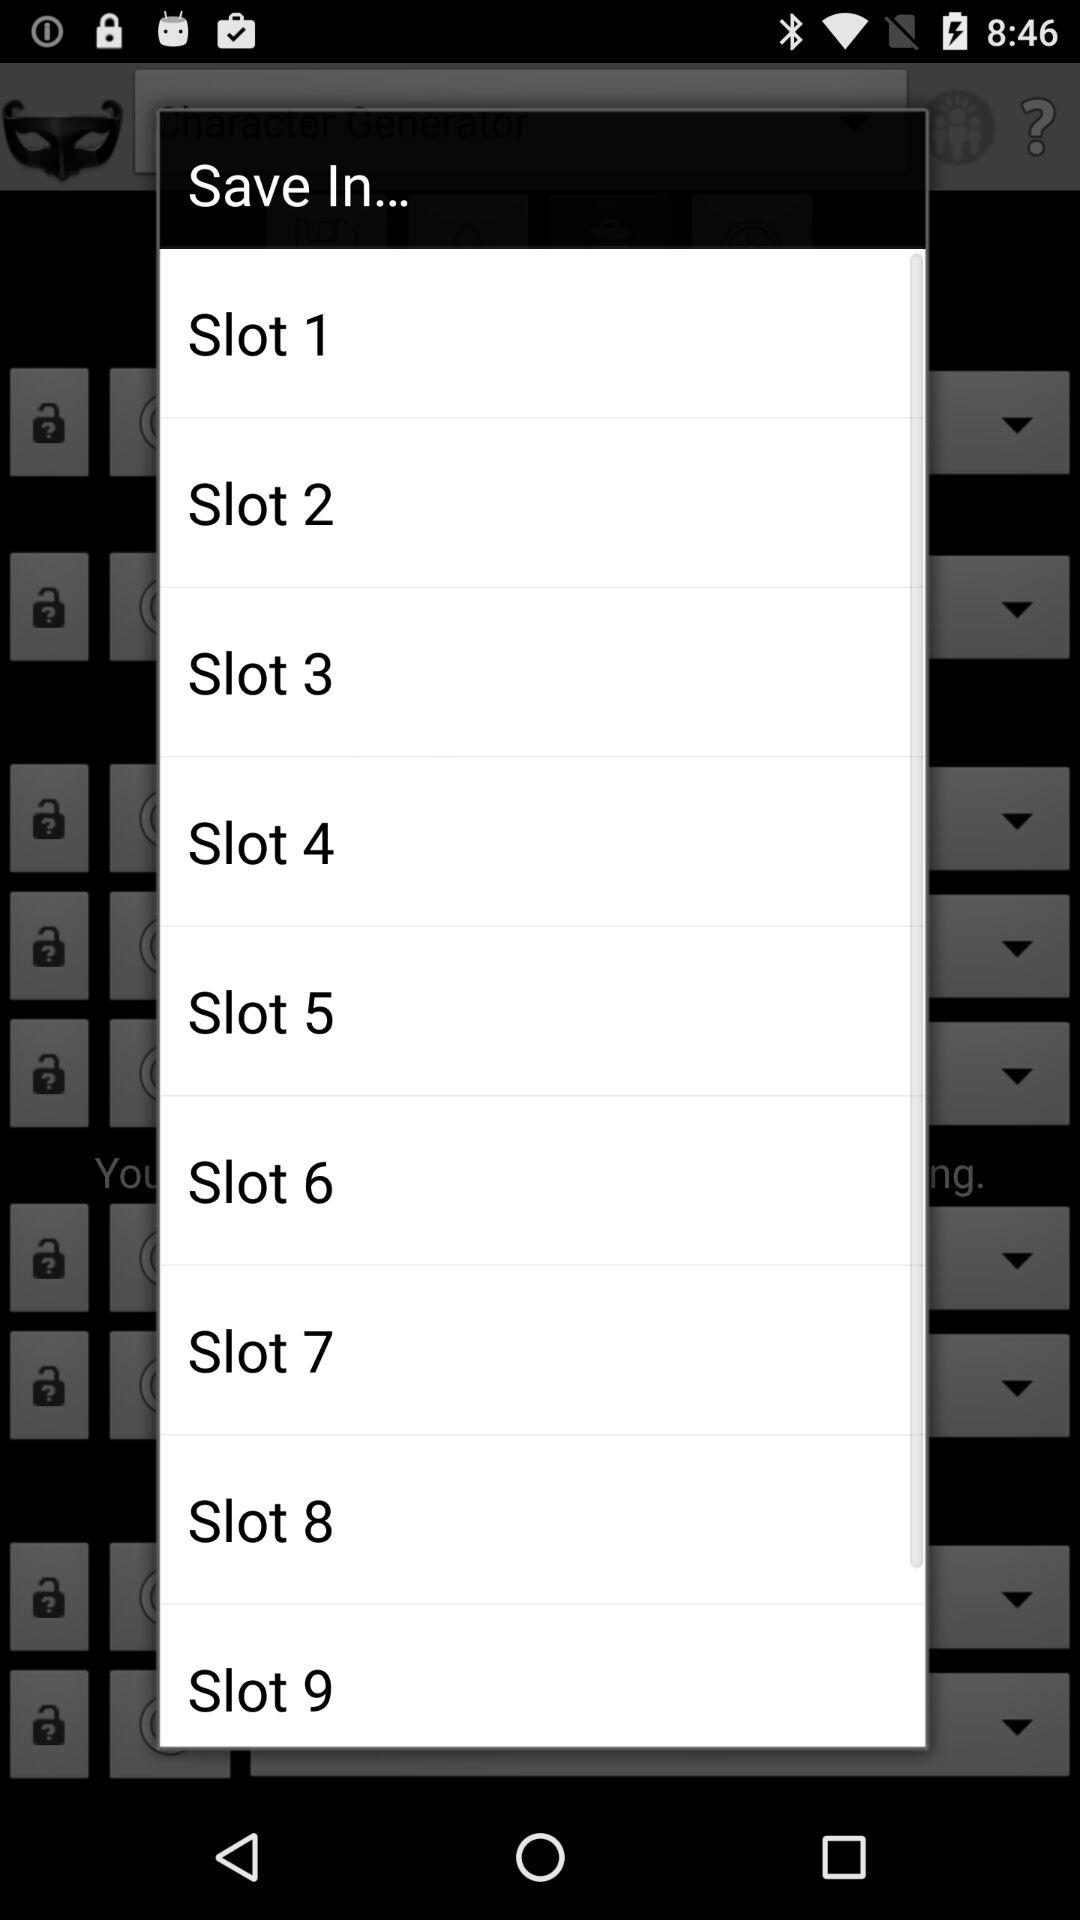How many slots are there in the Save In dialog?
Answer the question using a single word or phrase. 9 